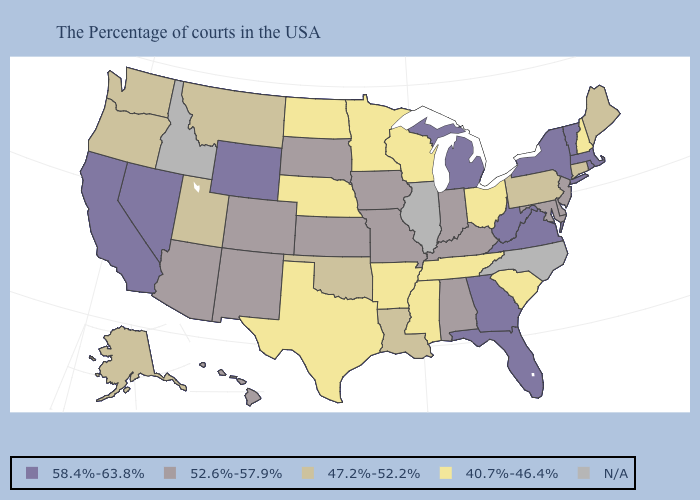Name the states that have a value in the range 52.6%-57.9%?
Short answer required. New Jersey, Delaware, Maryland, Kentucky, Indiana, Alabama, Missouri, Iowa, Kansas, South Dakota, Colorado, New Mexico, Arizona, Hawaii. Name the states that have a value in the range 47.2%-52.2%?
Keep it brief. Maine, Connecticut, Pennsylvania, Louisiana, Oklahoma, Utah, Montana, Washington, Oregon, Alaska. What is the highest value in states that border Idaho?
Be succinct. 58.4%-63.8%. What is the highest value in the USA?
Give a very brief answer. 58.4%-63.8%. Name the states that have a value in the range N/A?
Write a very short answer. North Carolina, Illinois, Idaho. Name the states that have a value in the range 47.2%-52.2%?
Write a very short answer. Maine, Connecticut, Pennsylvania, Louisiana, Oklahoma, Utah, Montana, Washington, Oregon, Alaska. Does California have the lowest value in the USA?
Keep it brief. No. What is the lowest value in the MidWest?
Short answer required. 40.7%-46.4%. Name the states that have a value in the range 47.2%-52.2%?
Short answer required. Maine, Connecticut, Pennsylvania, Louisiana, Oklahoma, Utah, Montana, Washington, Oregon, Alaska. Name the states that have a value in the range N/A?
Concise answer only. North Carolina, Illinois, Idaho. Name the states that have a value in the range N/A?
Quick response, please. North Carolina, Illinois, Idaho. What is the highest value in the West ?
Give a very brief answer. 58.4%-63.8%. Does Alabama have the lowest value in the USA?
Keep it brief. No. What is the value of Colorado?
Answer briefly. 52.6%-57.9%. 